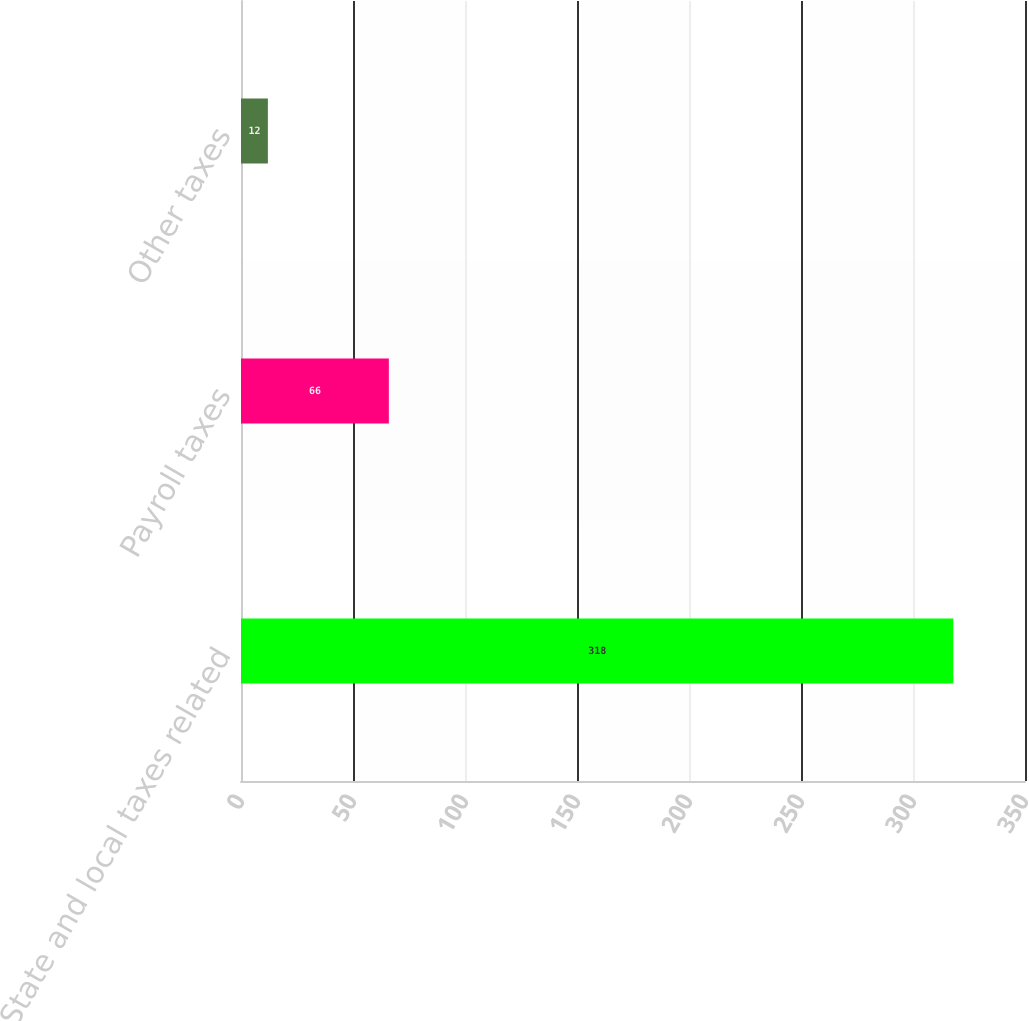Convert chart to OTSL. <chart><loc_0><loc_0><loc_500><loc_500><bar_chart><fcel>State and local taxes related<fcel>Payroll taxes<fcel>Other taxes<nl><fcel>318<fcel>66<fcel>12<nl></chart> 